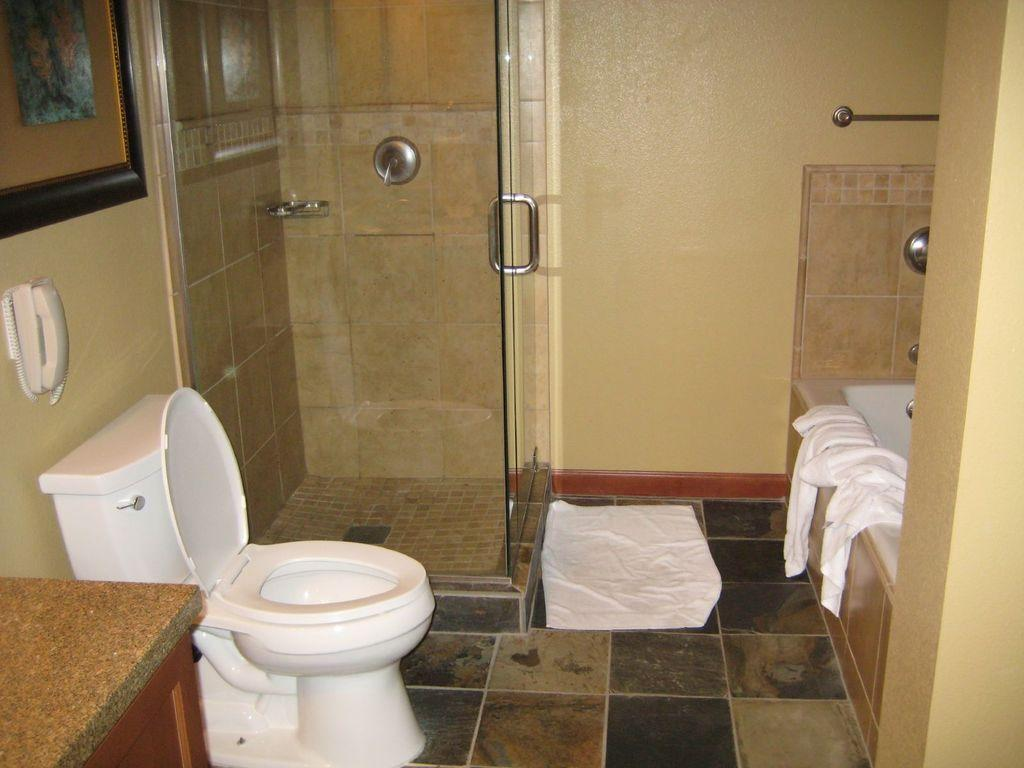What color are the walls in the image? The walls in the image are painted yellow. What type of fixture is present in the image? There is a toilet in the image. What type of doors can be seen in the image? Glass doors are present in the image. What type of flooring is visible in the image? The floor in the image is tiled. What type of communication device is present in the image? There is a telephone in the image. What type of furniture is visible in the image? A wooden cabinet is visible in the image. How is the loaf of bread distributed in the image? There is no loaf of bread present in the image. What type of tray is used to serve the food in the image? There is no tray present in the image. 